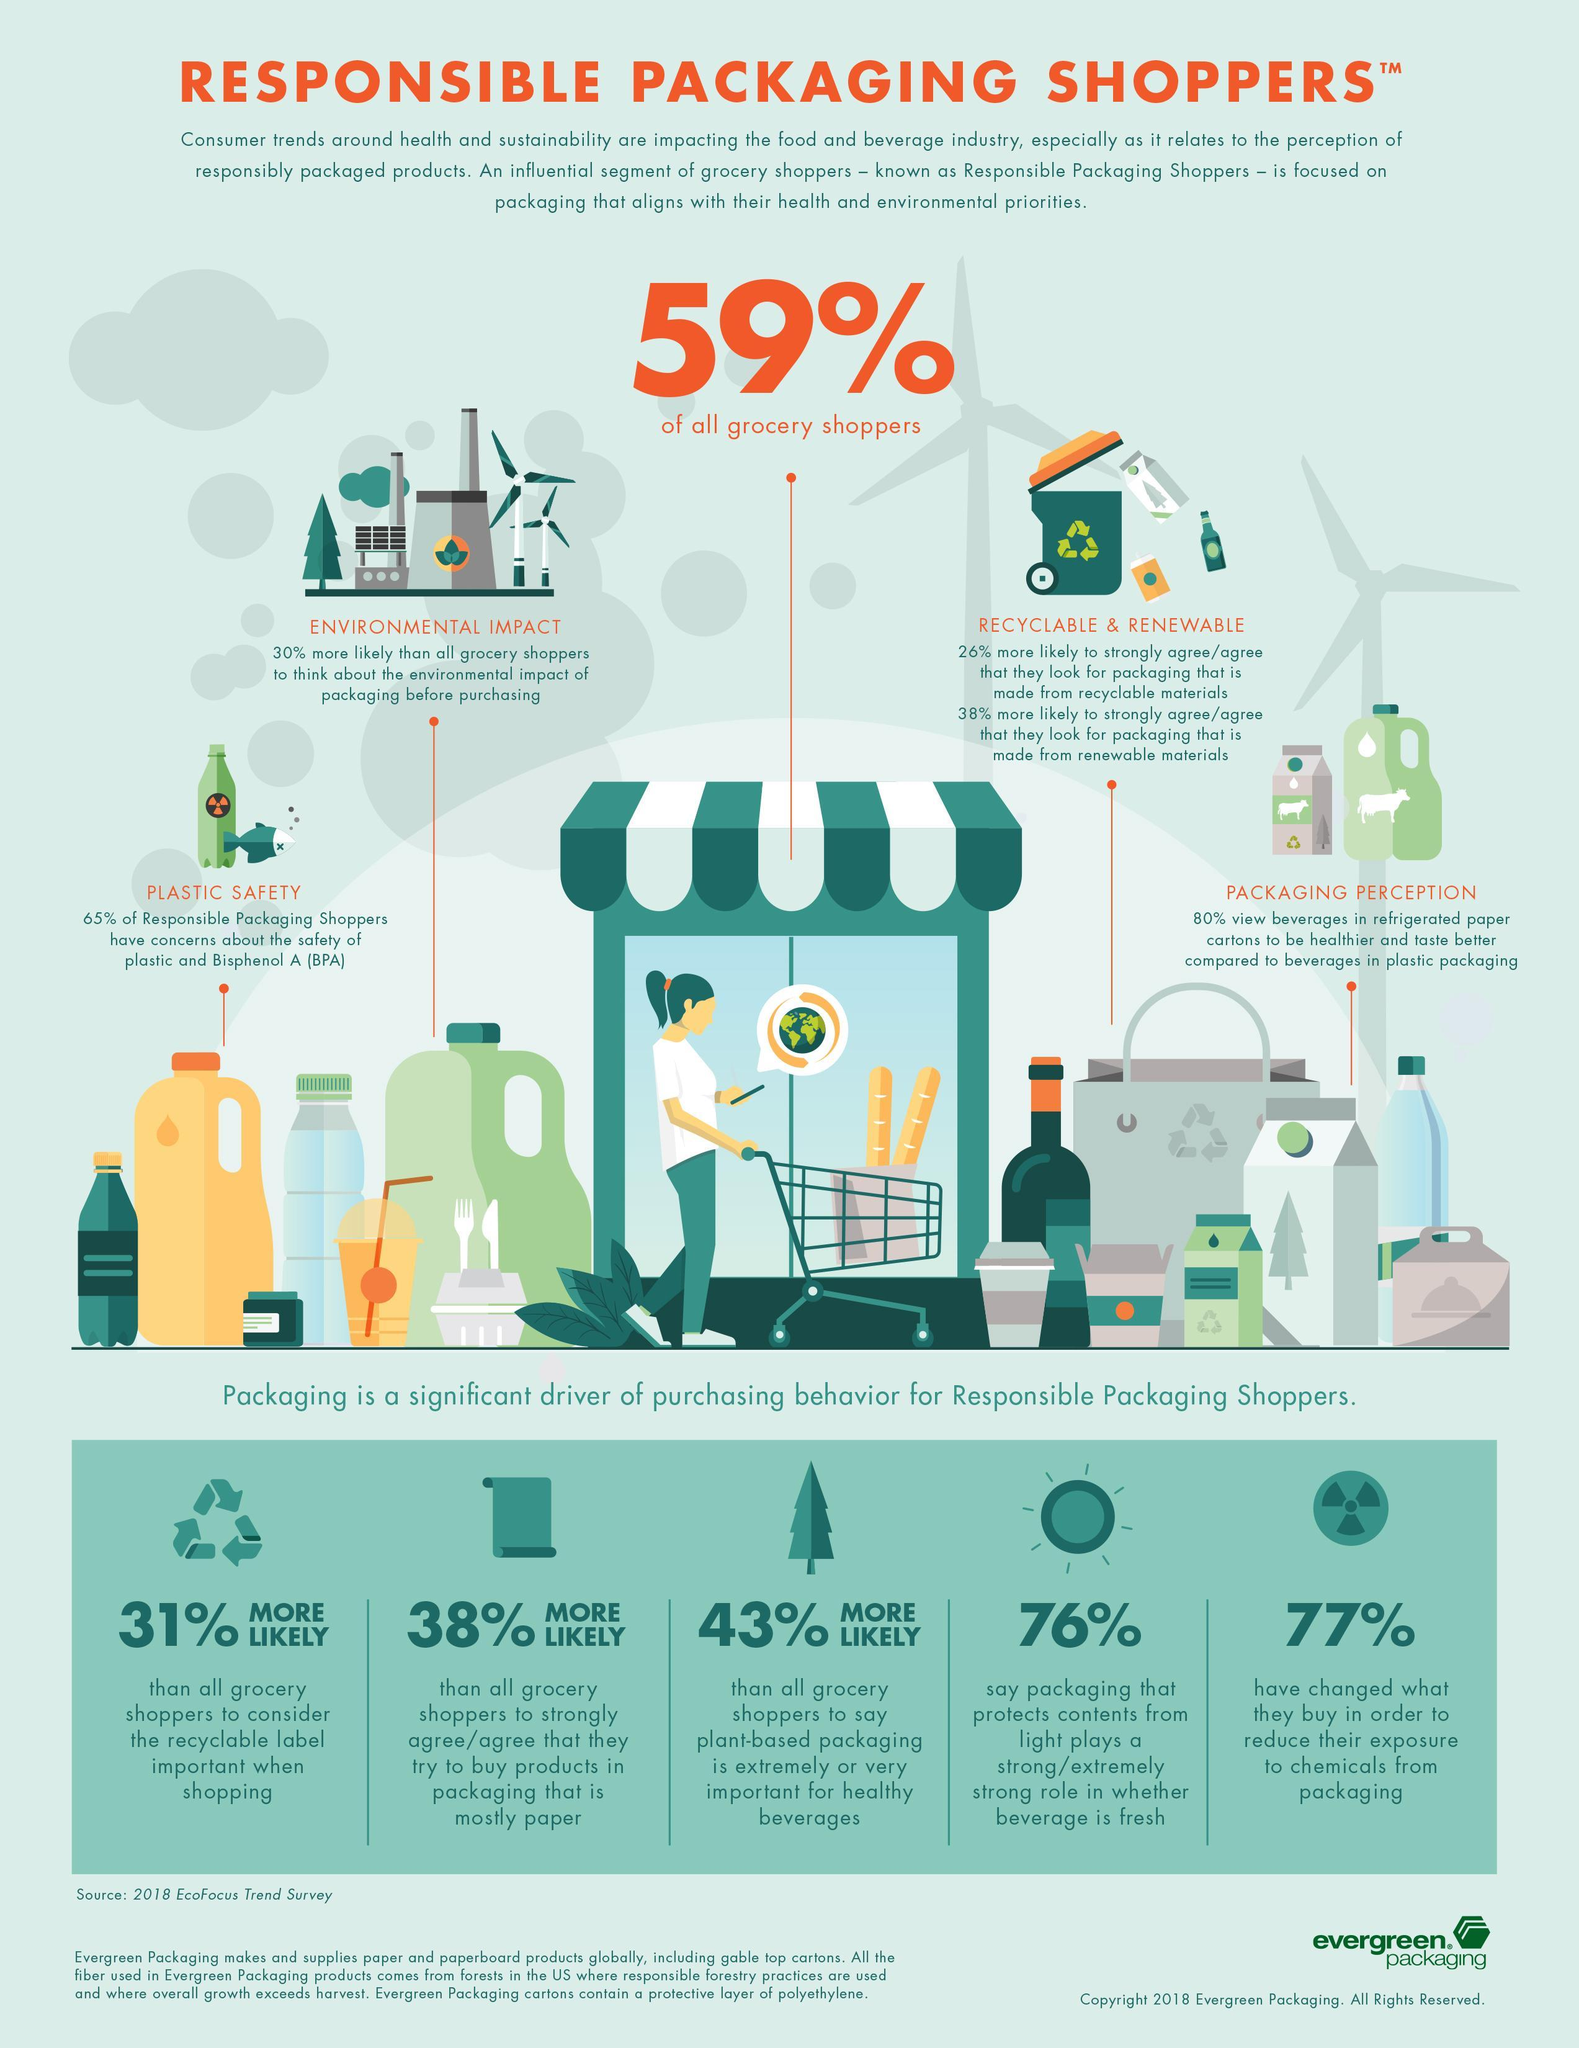What percentage of Responsible Packaging Shoppers have no concern about the safety of plastic and Bisphenol A?
Answer the question with a short phrase. 35% 